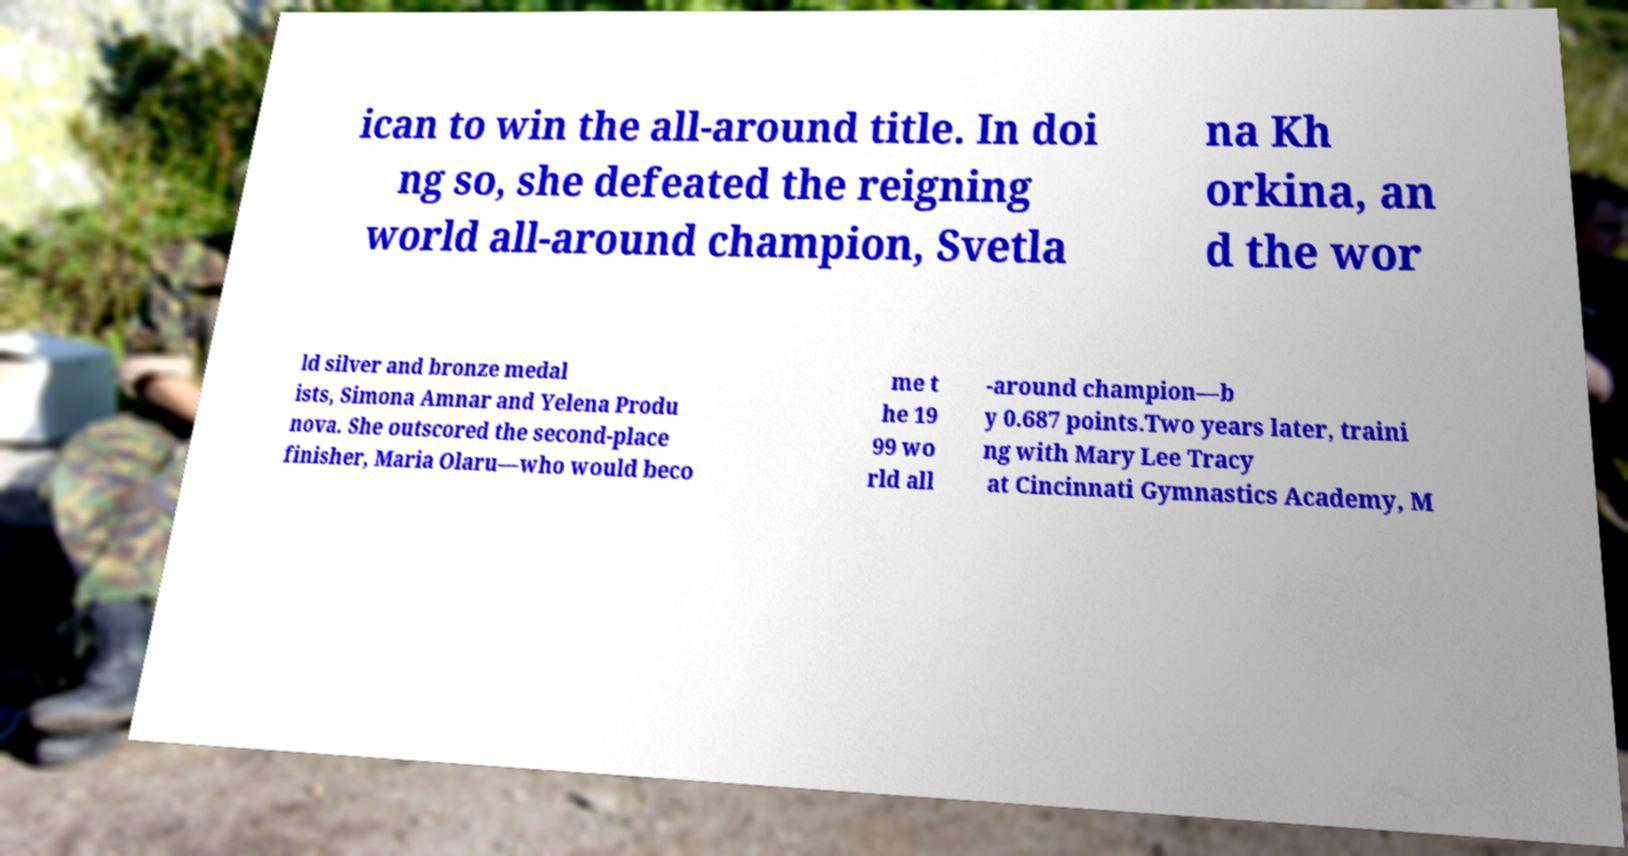Can you read and provide the text displayed in the image?This photo seems to have some interesting text. Can you extract and type it out for me? ican to win the all-around title. In doi ng so, she defeated the reigning world all-around champion, Svetla na Kh orkina, an d the wor ld silver and bronze medal ists, Simona Amnar and Yelena Produ nova. She outscored the second-place finisher, Maria Olaru—who would beco me t he 19 99 wo rld all -around champion—b y 0.687 points.Two years later, traini ng with Mary Lee Tracy at Cincinnati Gymnastics Academy, M 